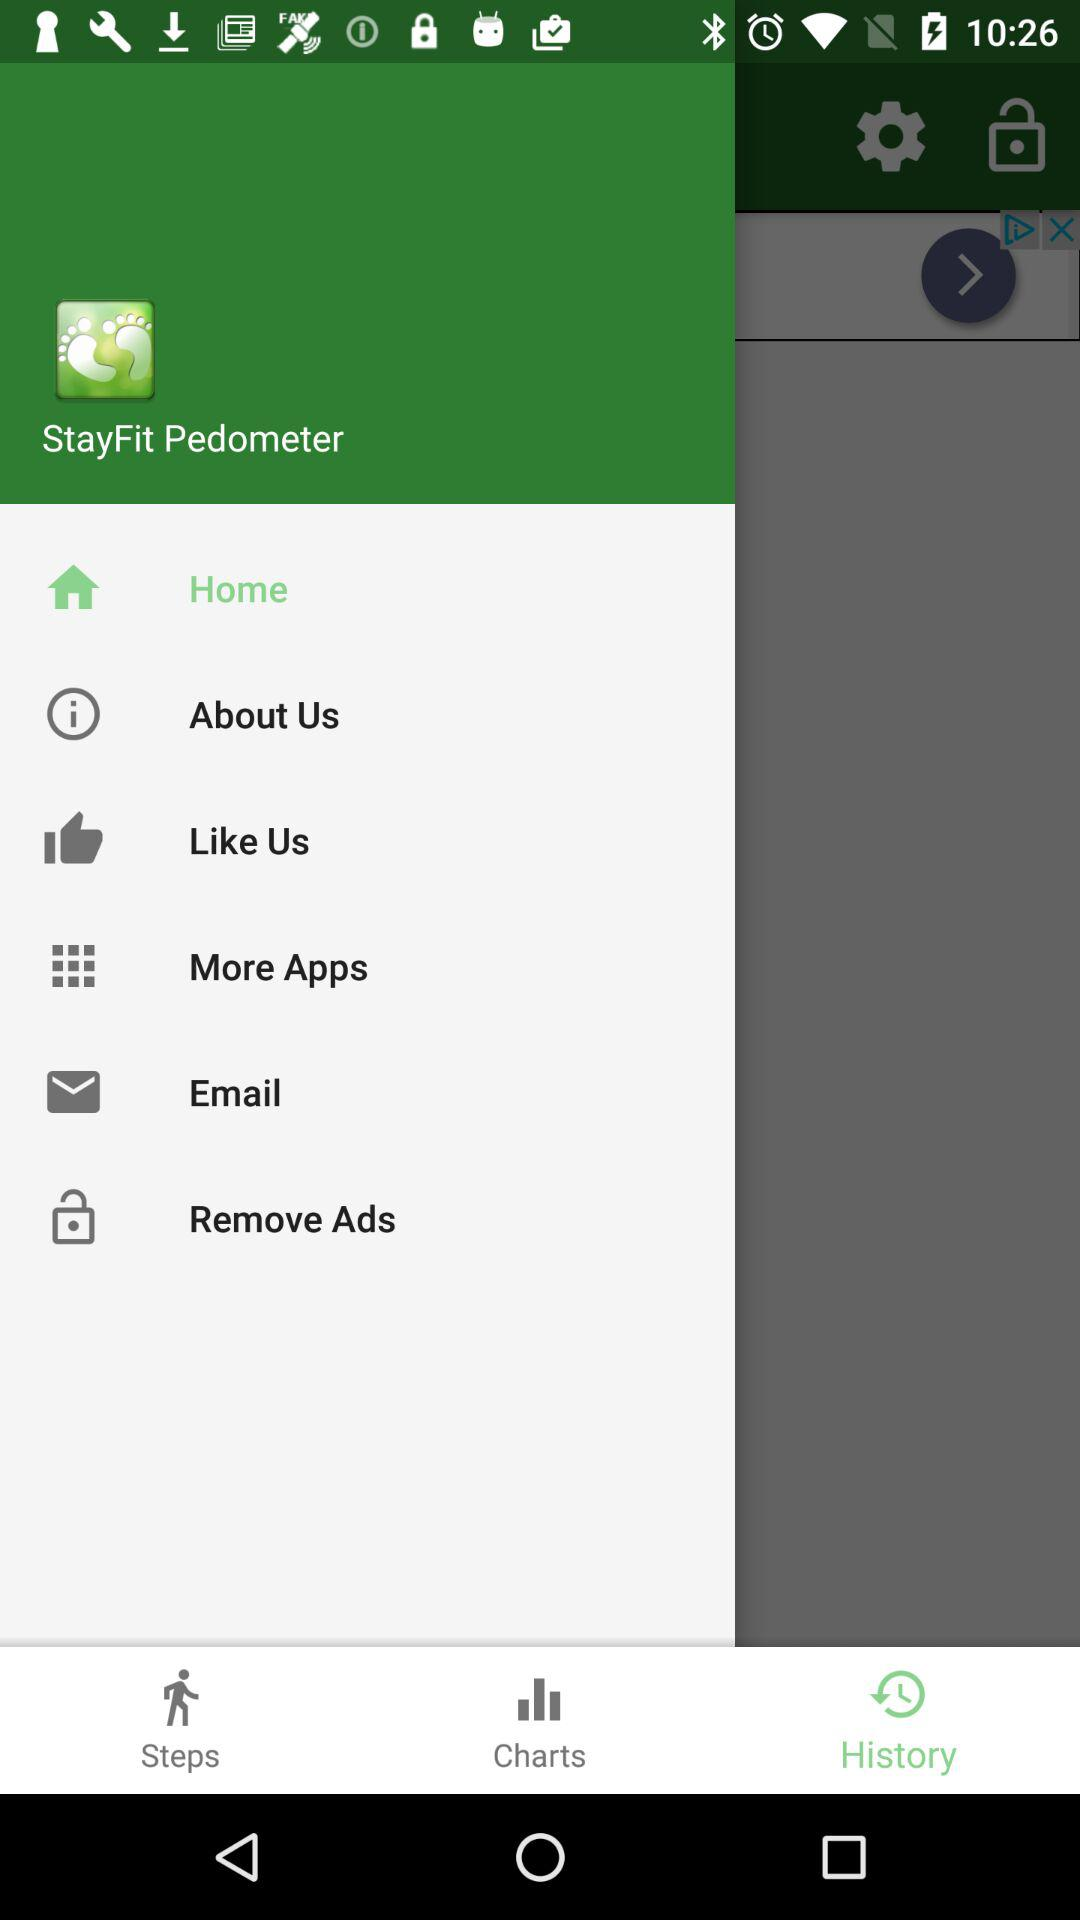What is the app name? The app name is "StayFit Pedometer". 